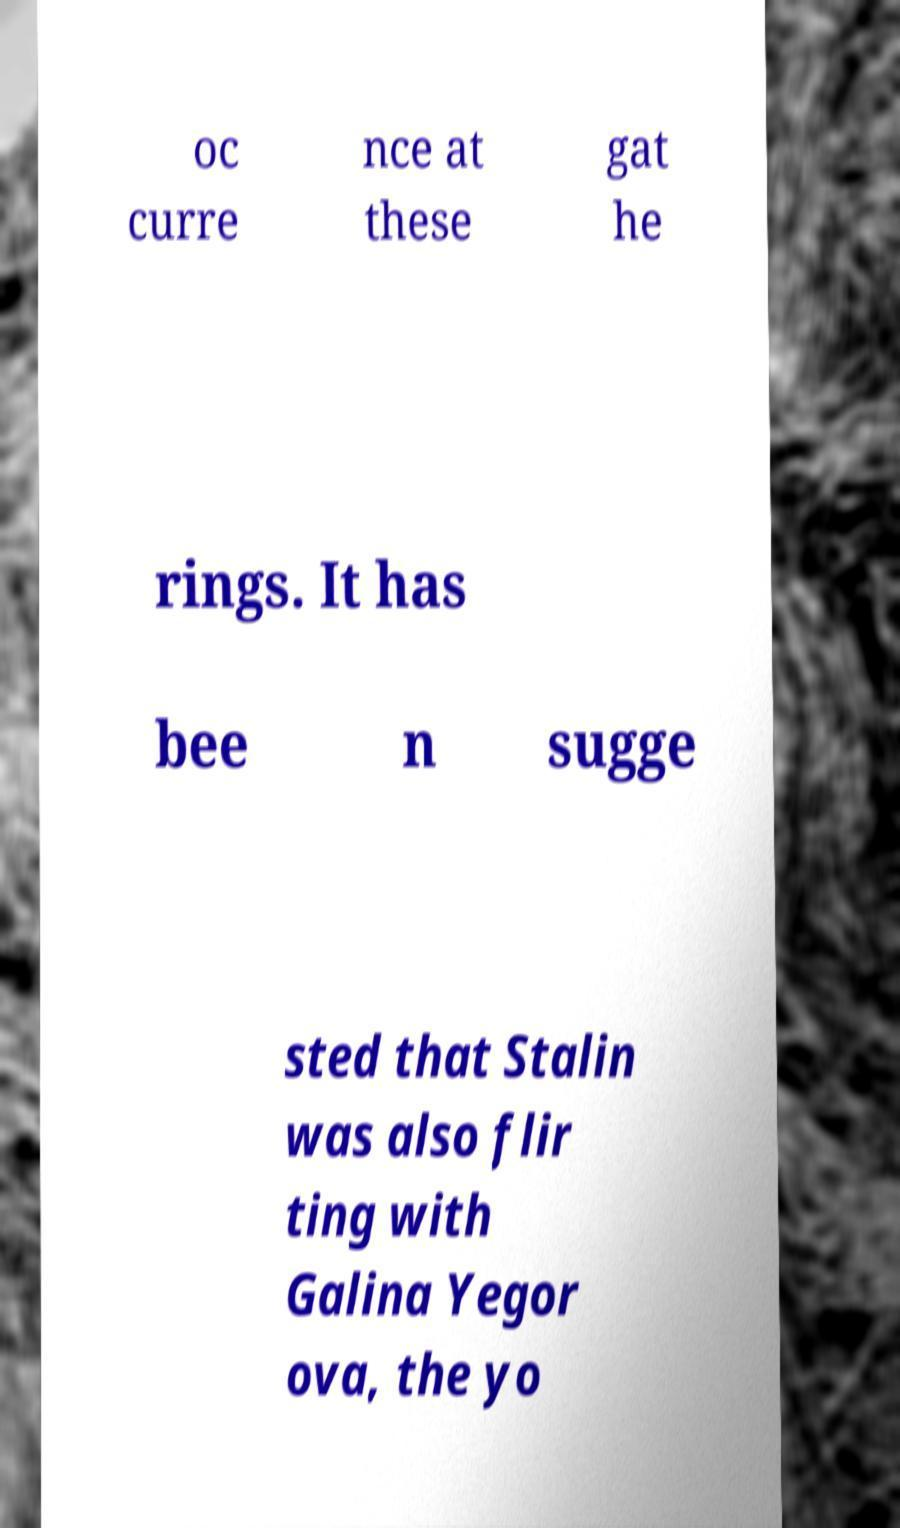Can you read and provide the text displayed in the image?This photo seems to have some interesting text. Can you extract and type it out for me? oc curre nce at these gat he rings. It has bee n sugge sted that Stalin was also flir ting with Galina Yegor ova, the yo 